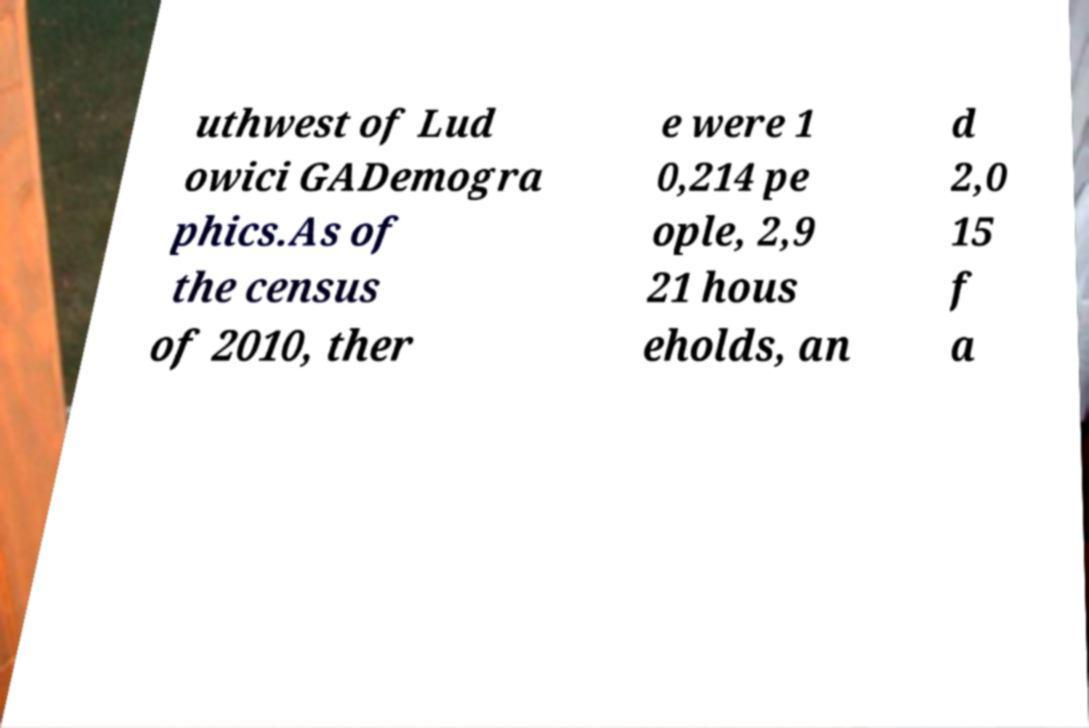Could you assist in decoding the text presented in this image and type it out clearly? uthwest of Lud owici GADemogra phics.As of the census of 2010, ther e were 1 0,214 pe ople, 2,9 21 hous eholds, an d 2,0 15 f a 